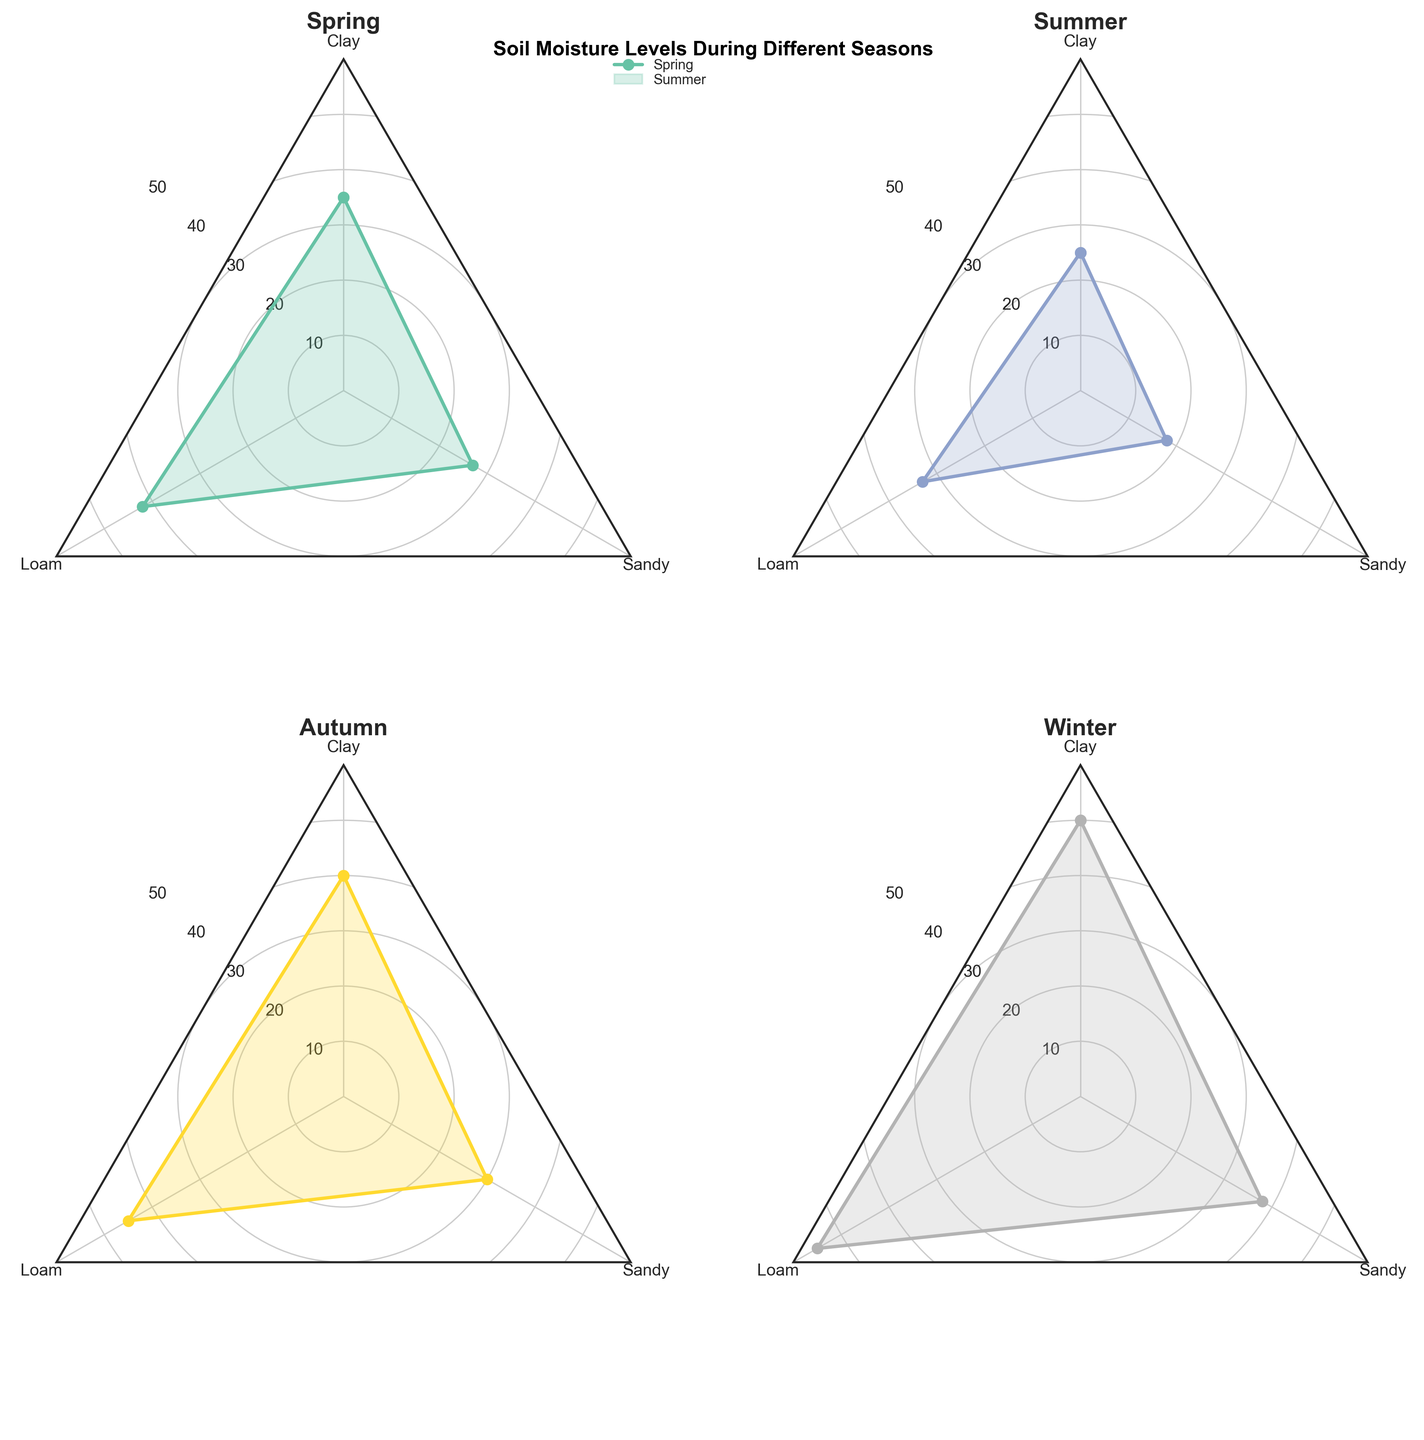Which season has the highest soil moisture for clay soil? By examining the radar charts of each season for the value corresponding to clay, the winter season shows the highest soil moisture level.
Answer: Winter What is the soil moisture difference between loam and sandy soil in spring? In the radar chart for spring, loam has a soil moisture level of 42, and sandy soil has a level of 27. The difference is 42 - 27 = 15.
Answer: 15 During which season is the difference in soil moisture content between loam and clay the greatest? By checking each season's radar chart for the difference between loam and clay soil, winter has the largest difference with loam (55) and clay (50), giving a difference of 5.
Answer: Winter Which soil type has the most consistent moisture level across all seasons? By observing each soil type's relative consistency across the four radar charts, clay soil shows relatively consistent moisture levels as compared to loam and sandy soil which show more variance.
Answer: Clay In which season is sandy soil moisture the lowest? By comparing the radar charts, summer shows the lowest sandy soil moisture level at 18.
Answer: Summer What are the soil moisture levels for all soil types in autumn? By examining the radar chart for autumn, the values are: Clay (40), Loam (45), and Sandy (30).
Answer: Clay: 40, Loam: 45, Sandy: 30 What is the average soil moisture level for loam soil across all seasons? Sum the loam moisture levels for all seasons: 42 (Spring) + 33 (Summer) + 45 (Autumn) + 55 (Winter) = 175. Divide by 4 to get the average: 175 / 4 = 43.75.
Answer: 43.75 Which season shows the greatest variation in soil moisture levels among the three soil types? Examining each season, summer shows the greatest variation with a high value of 33 for loam and a low value of 18 for sandy, giving a difference of 15.
Answer: Summer How does the soil moisture level of clay soil in summer compare to loam soil in the same season? In summer, the soil moisture level of clay is 25 and for loam, it is 33. Therefore, loam soil has a higher moisture level by 8.
Answer: Loam > Clay by 8 